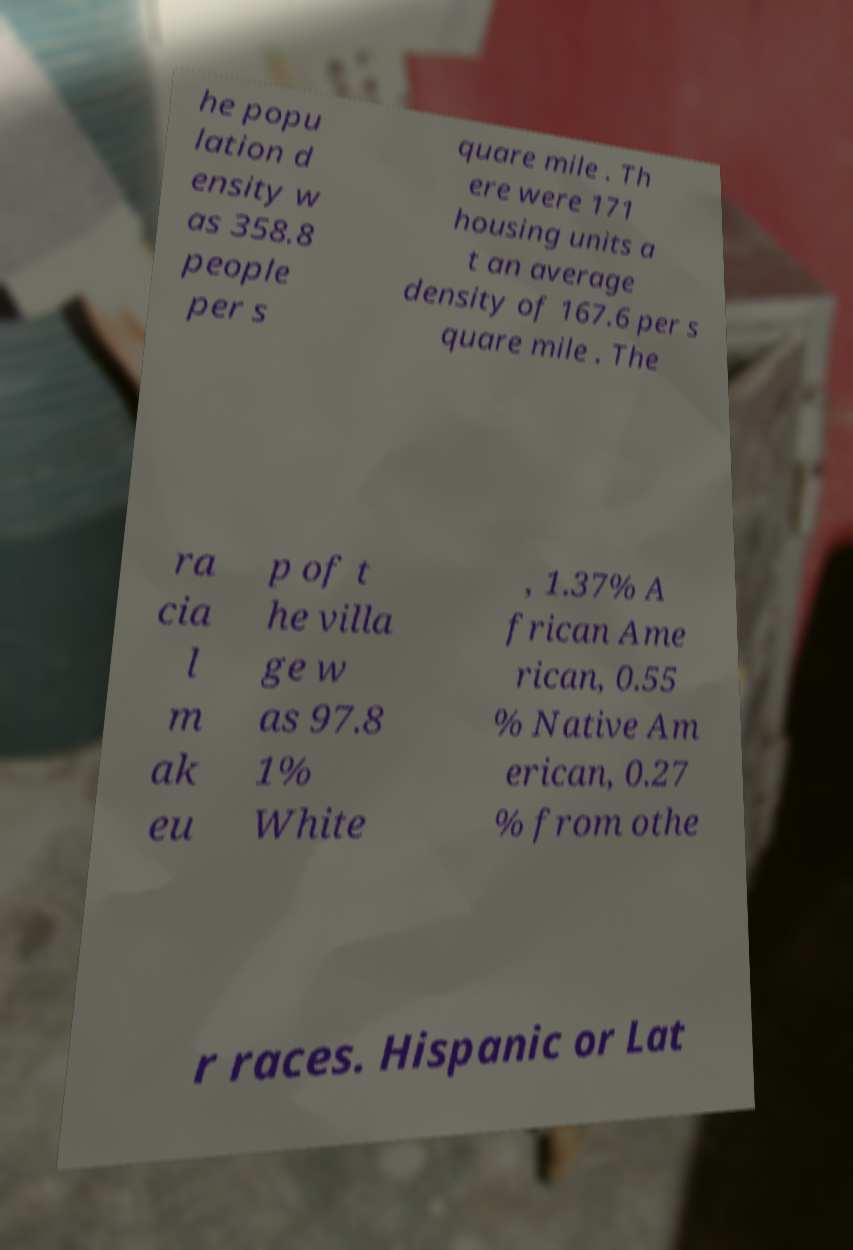What messages or text are displayed in this image? I need them in a readable, typed format. he popu lation d ensity w as 358.8 people per s quare mile . Th ere were 171 housing units a t an average density of 167.6 per s quare mile . The ra cia l m ak eu p of t he villa ge w as 97.8 1% White , 1.37% A frican Ame rican, 0.55 % Native Am erican, 0.27 % from othe r races. Hispanic or Lat 